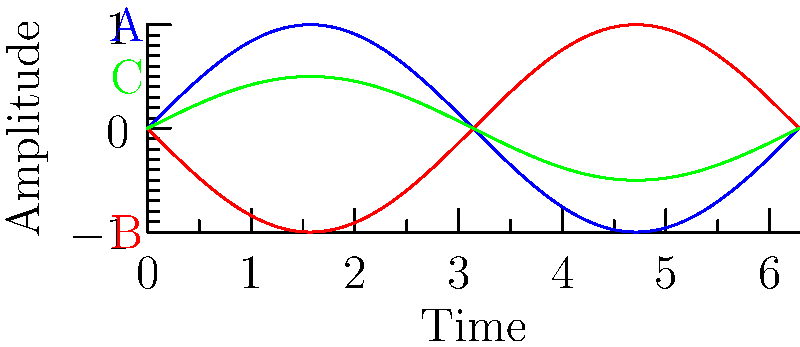Look at the sound wave diagrams labeled A, B, and C. Which two waves are congruent to each other? To determine which waves are congruent, we need to compare their shapes, sizes, and positions. Let's examine each wave:

1. Wave A (blue): This is a standard sine wave with amplitude 1.
2. Wave B (red): This wave has the same shape and amplitude as Wave A, but it's shifted horizontally.
3. Wave C (green): This wave has the same shape as A and B, but its amplitude is smaller (0.5).

Congruent shapes are identical in shape and size, but can be in different positions. Based on this:

- Waves A and B have the same shape and size (amplitude), but B is shifted horizontally. This shift doesn't affect congruence.
- Wave C has the same shape but a different size (smaller amplitude) compared to A and B.

Therefore, Waves A and B are congruent to each other, while C is not congruent to either A or B.
Answer: A and B 